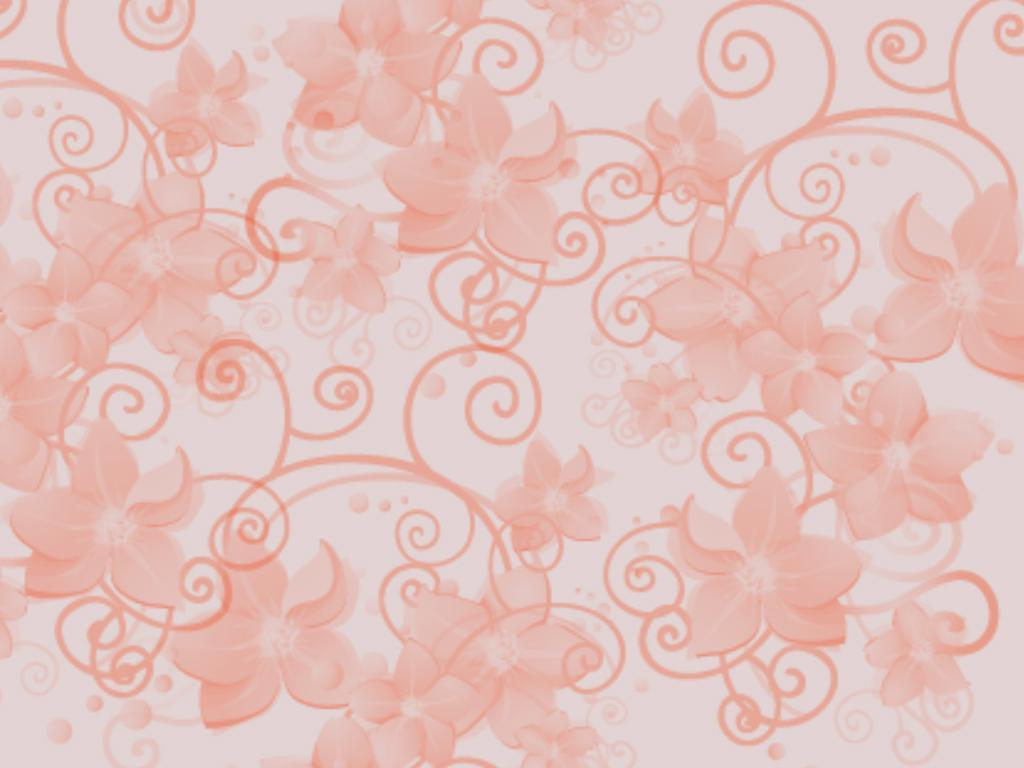What is the texture of the image? The image has an art canvas texture. How many feet can be seen on the art canvas in the image? There are no feet visible on the art canvas in the image, as it is a texture and not a representation of a scene or object. 